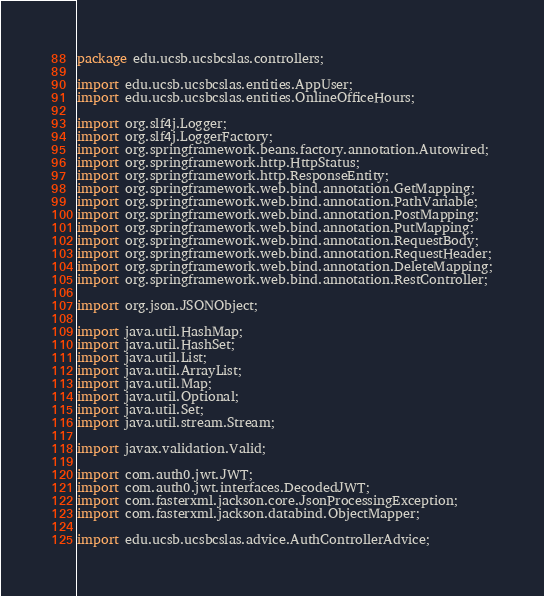<code> <loc_0><loc_0><loc_500><loc_500><_Java_>package edu.ucsb.ucsbcslas.controllers;

import edu.ucsb.ucsbcslas.entities.AppUser;
import edu.ucsb.ucsbcslas.entities.OnlineOfficeHours;

import org.slf4j.Logger;
import org.slf4j.LoggerFactory;
import org.springframework.beans.factory.annotation.Autowired;
import org.springframework.http.HttpStatus;
import org.springframework.http.ResponseEntity;
import org.springframework.web.bind.annotation.GetMapping;
import org.springframework.web.bind.annotation.PathVariable;
import org.springframework.web.bind.annotation.PostMapping;
import org.springframework.web.bind.annotation.PutMapping;
import org.springframework.web.bind.annotation.RequestBody;
import org.springframework.web.bind.annotation.RequestHeader;
import org.springframework.web.bind.annotation.DeleteMapping;
import org.springframework.web.bind.annotation.RestController;

import org.json.JSONObject;

import java.util.HashMap;
import java.util.HashSet;
import java.util.List;
import java.util.ArrayList;
import java.util.Map;
import java.util.Optional;
import java.util.Set;
import java.util.stream.Stream;

import javax.validation.Valid;

import com.auth0.jwt.JWT;
import com.auth0.jwt.interfaces.DecodedJWT;
import com.fasterxml.jackson.core.JsonProcessingException;
import com.fasterxml.jackson.databind.ObjectMapper;

import edu.ucsb.ucsbcslas.advice.AuthControllerAdvice;</code> 